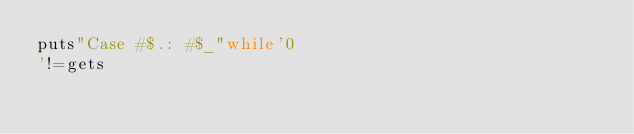<code> <loc_0><loc_0><loc_500><loc_500><_Ruby_>puts"Case #$.: #$_"while'0
'!=gets</code> 